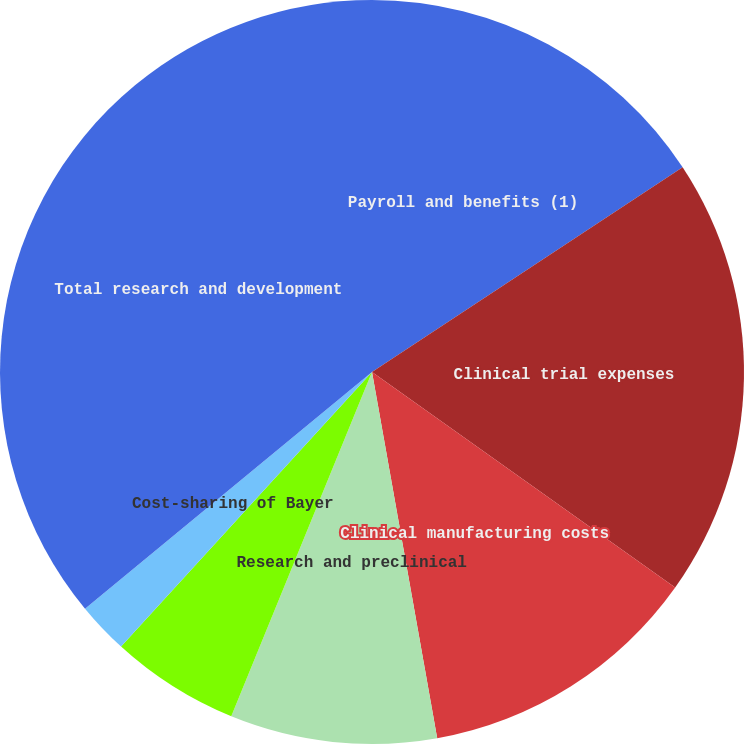Convert chart to OTSL. <chart><loc_0><loc_0><loc_500><loc_500><pie_chart><fcel>Payroll and benefits (1)<fcel>Clinical trial expenses<fcel>Clinical manufacturing costs<fcel>Research and preclinical<fcel>Occupancy and other operating<fcel>Cost-sharing of Bayer<fcel>Total research and development<nl><fcel>15.73%<fcel>19.11%<fcel>12.36%<fcel>8.98%<fcel>5.61%<fcel>2.24%<fcel>35.98%<nl></chart> 